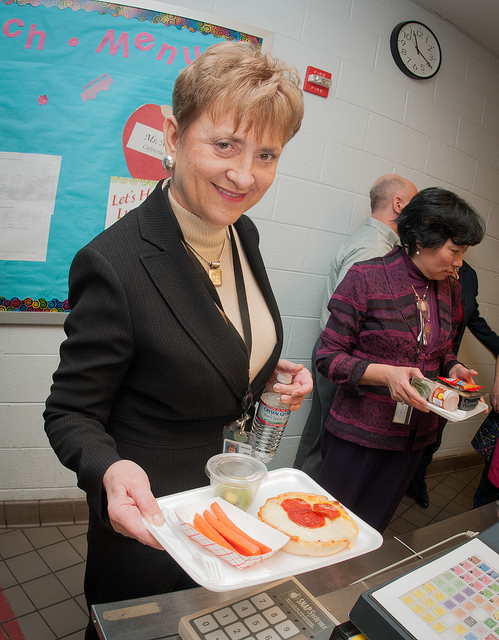Can you describe the environment where the food is being served? This appears to be a school cafeteria, as evidenced by the menu posters on the wall and the food serving line set up. Several adults and perhaps cafeteria staff or teachers are visible, further indicating an educational setting. What seems to be the focus of the menu being offered? The focus of the menu seems to be on providing balanced, healthy meal options. This includes items like pizza, which might be made with a whole wheat base and lean cheese, along with fresh vegetables like carrots. 